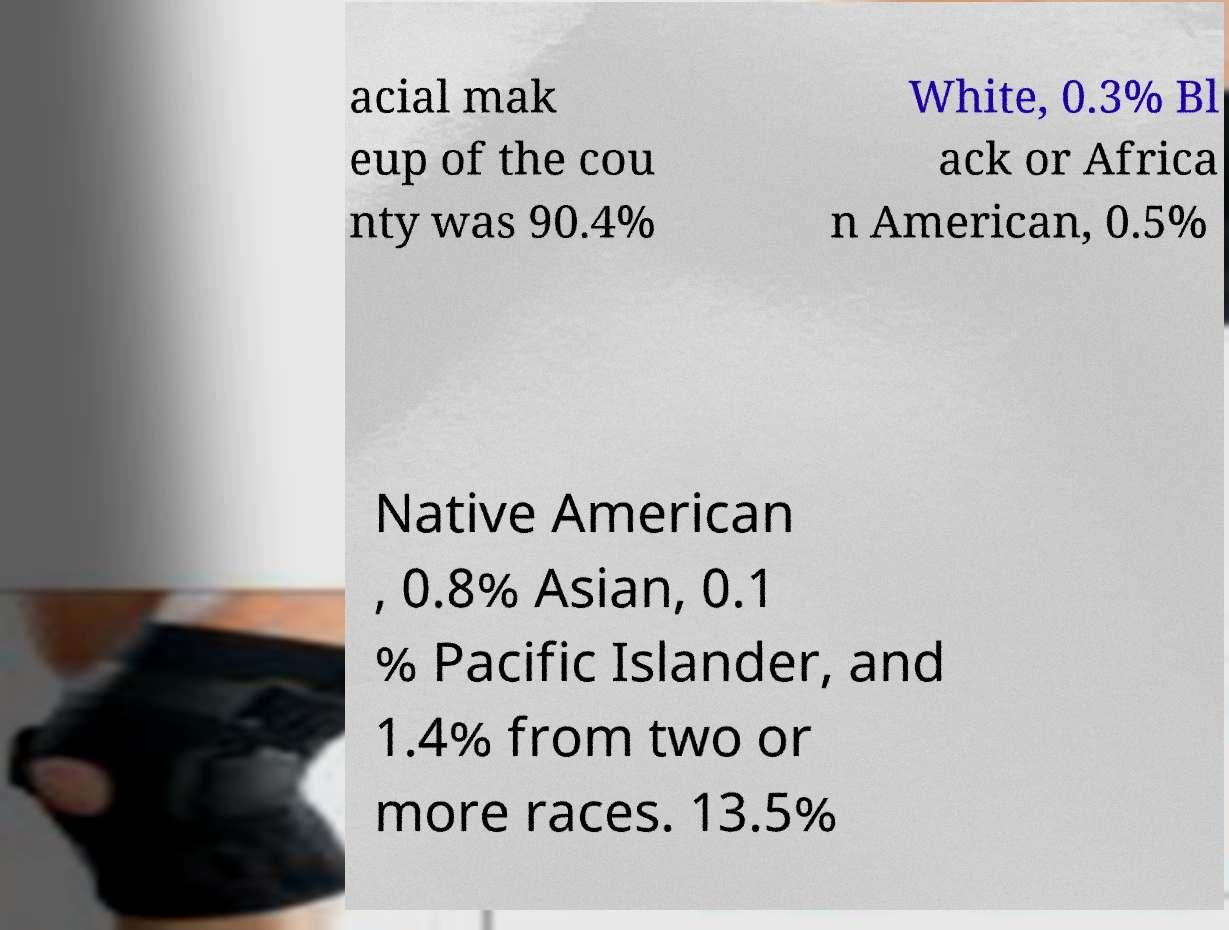Please identify and transcribe the text found in this image. acial mak eup of the cou nty was 90.4% White, 0.3% Bl ack or Africa n American, 0.5% Native American , 0.8% Asian, 0.1 % Pacific Islander, and 1.4% from two or more races. 13.5% 